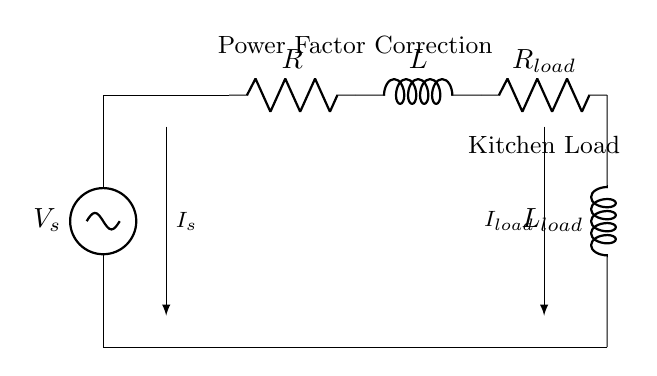What is the voltage source in this circuit? The voltage source is denoted as V_s, which is positioned on the left side of the circuit diagram, supplying electrical power to the circuit.
Answer: V_s What is the primary function of the components in this circuit? The circuit components are primarily used for power factor correction, as indicated by the label "Power Factor Correction" above the resistor and inductor.
Answer: Power Factor Correction What is the load resistance designated in the circuit? The load resistance is indicated as R_load, located on the right side of the circuit, designed to handle the power supplied by the circuit.
Answer: R_load What are the two main types of components represented in this RL circuit? The circuit contains resistive and inductive components; specifically, there is a resistor denoted as R, and an inductor denoted as L.
Answer: Resistors and Inductors How does the inductor affect the current in the circuit? The inductor stores energy in a magnetic field when current flows through it and impacts the phase relationship between current and voltage, which relates to power factor.
Answer: Affects phase relationship What is the role of the resistor R in this circuit configuration? The resistor R limits the current through the circuit and dissipates power in the form of heat, contributing to the overall resistance of the RL circuit.
Answer: Limits current What is the significance of power factor correction in a commercial kitchen appliance circuit? Power factor correction ensures that the appliances use electricity efficiently by minimizing wasted energy, which is essential for large kitchen operations to reduce energy costs.
Answer: Reduces energy costs 